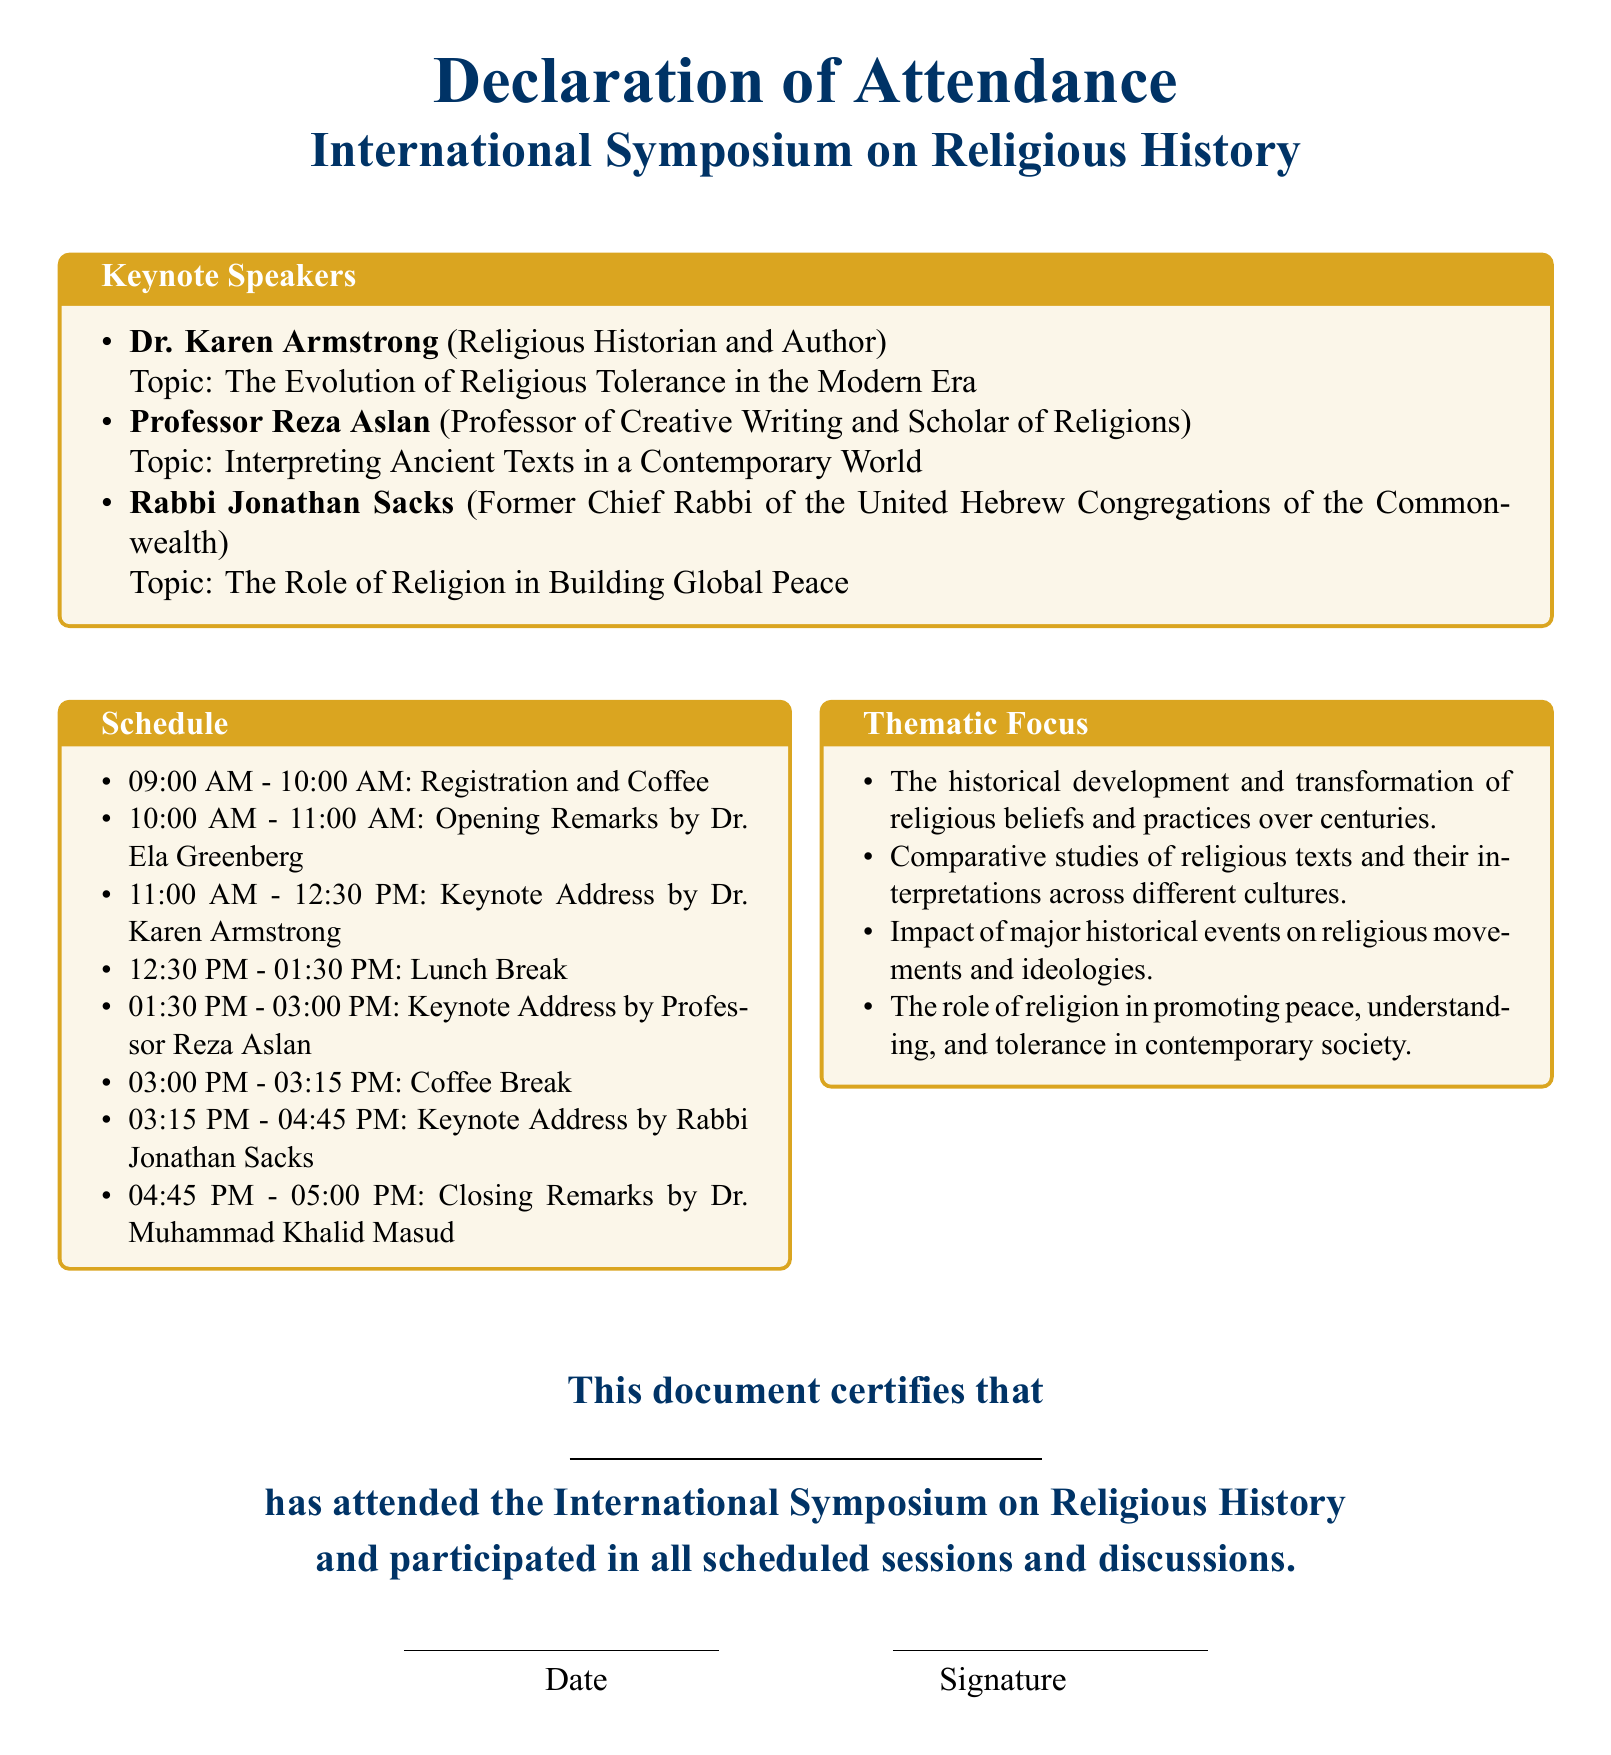What is the title of the symposium? The title of the symposium is stated prominently at the top of the document.
Answer: International Symposium on Religious History Who is the first keynote speaker? This information is found in the section detailing keynote speakers in the document.
Answer: Dr. Karen Armstrong What is the topic of Rabbi Jonathan Sacks' keynote address? The topic is provided in the list of keynote speakers and their respective topics.
Answer: The Role of Religion in Building Global Peace What time does the registration begin? The schedule section provides the specific timing for registration.
Answer: 09:00 AM Who gives the closing remarks? This information can be found in the schedule section, specifying the individual responsible for closing remarks.
Answer: Dr. Muhammad Khalid Masud How many thematic focuses are listed in the document? The thematic focus section outlines the number of distinct themes discussed.
Answer: Four What is the duration of the lunch break? The timing in the schedule section indicates the length of the lunch break.
Answer: One hour What is the color theme of the document? The document specifies color themes used for various sections within.
Answer: Gold and dark blue What certification does this document provide? The document explicitly states the purpose of the certification.
Answer: Certification of attendance 